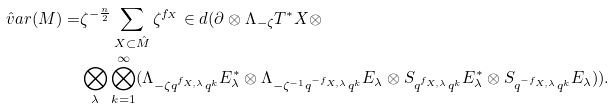Convert formula to latex. <formula><loc_0><loc_0><loc_500><loc_500>\hat { v } a r ( M ) = & \zeta ^ { - \frac { n } { 2 } } \sum _ { X \subset \hat { M } } \zeta ^ { f _ { X } } \in d ( \partial \otimes \Lambda _ { - \zeta } T ^ { * } X \otimes \\ & \bigotimes _ { \lambda } \bigotimes _ { k = 1 } ^ { \infty } ( \Lambda _ { - \zeta q ^ { f _ { X , \lambda } } q ^ { k } } E _ { \lambda } ^ { * } \otimes \Lambda _ { - \zeta ^ { - 1 } q ^ { - f _ { X , \lambda } } q ^ { k } } E _ { \lambda } \otimes S _ { q ^ { f _ { X , \lambda } } q ^ { k } } E _ { \lambda } ^ { * } \otimes S _ { q ^ { - f _ { X , \lambda } } q ^ { k } } E _ { \lambda } ) ) .</formula> 